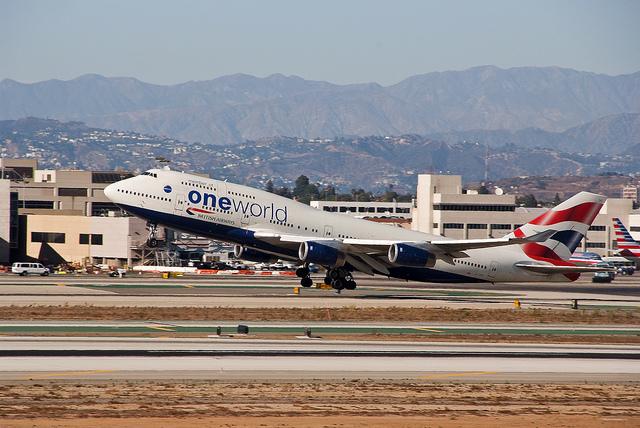Is the plane landing or taking off?
Keep it brief. Taking off. Is there a beach in the background?
Be succinct. No. Can this plane float?
Keep it brief. No. Is the landing gear down?
Be succinct. Yes. Is this a virgin airplane?
Quick response, please. No. What are the words on the plane?
Be succinct. One world. 